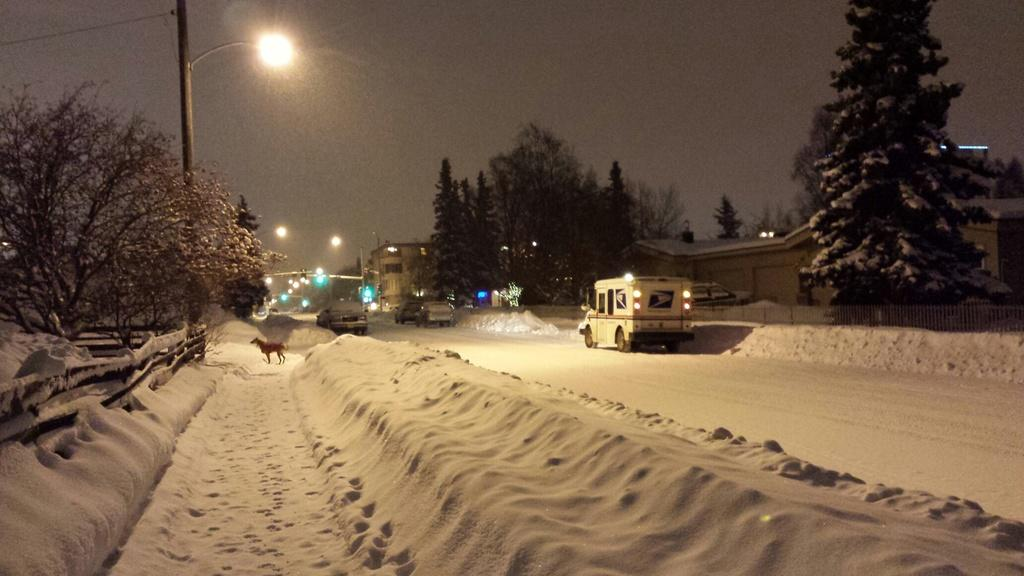What type of vehicles can be seen in the image? There are motor vehicles in the image. What animal is present in the image? There is a dog in the image. Where is the dog located in the image? The dog is on the snow. What can be seen in the background of the image? There is sky, a street pole, street lights, trees, an iron grill, and buildings visible in the background of the image. What is the weight of the dog in the image? The weight of the dog cannot be determined from the image alone, as it depends on the breed and size of the dog. 